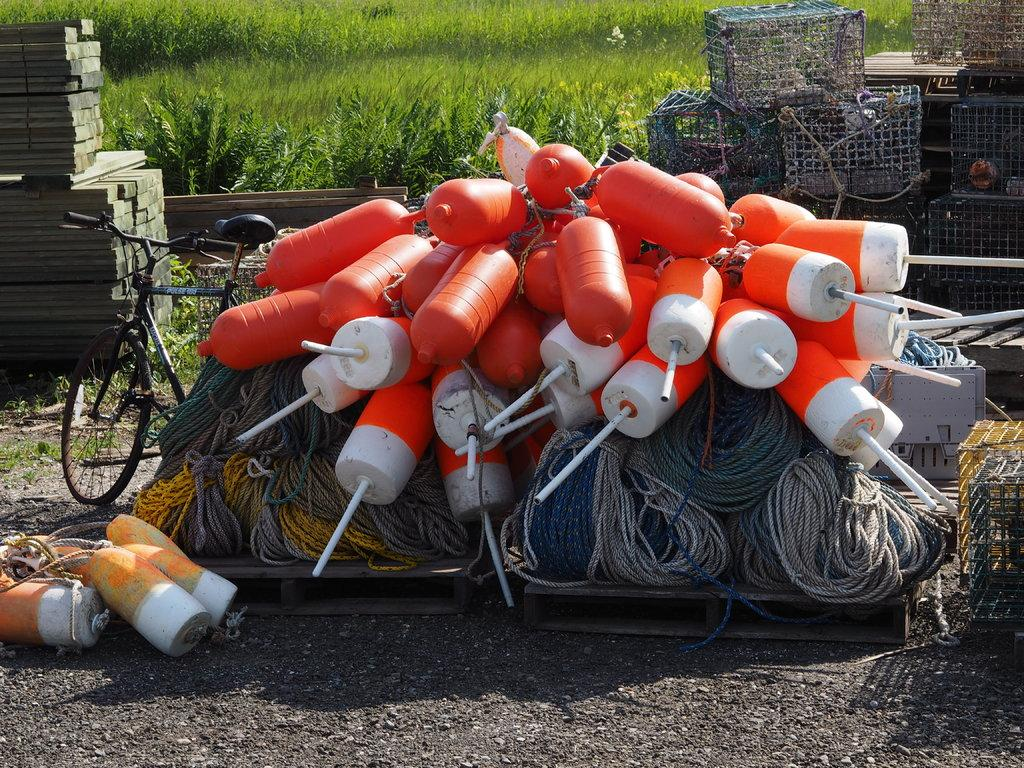What types of objects can be seen in the foreground of the image? There are ropes, mesh boxes, a wooden block, and a cycle in the foreground of the image. What material are the mesh boxes made of? The mesh boxes are made of a mesh material. What is the wooden block used for? The wooden block's purpose is not specified in the image. What type of terrain is visible at the top of the image? Grass is visible at the top of the image. What type of spring is visible in the image? There is no spring present in the image. How many ducks can be seen in the image? There are no ducks present in the image. 